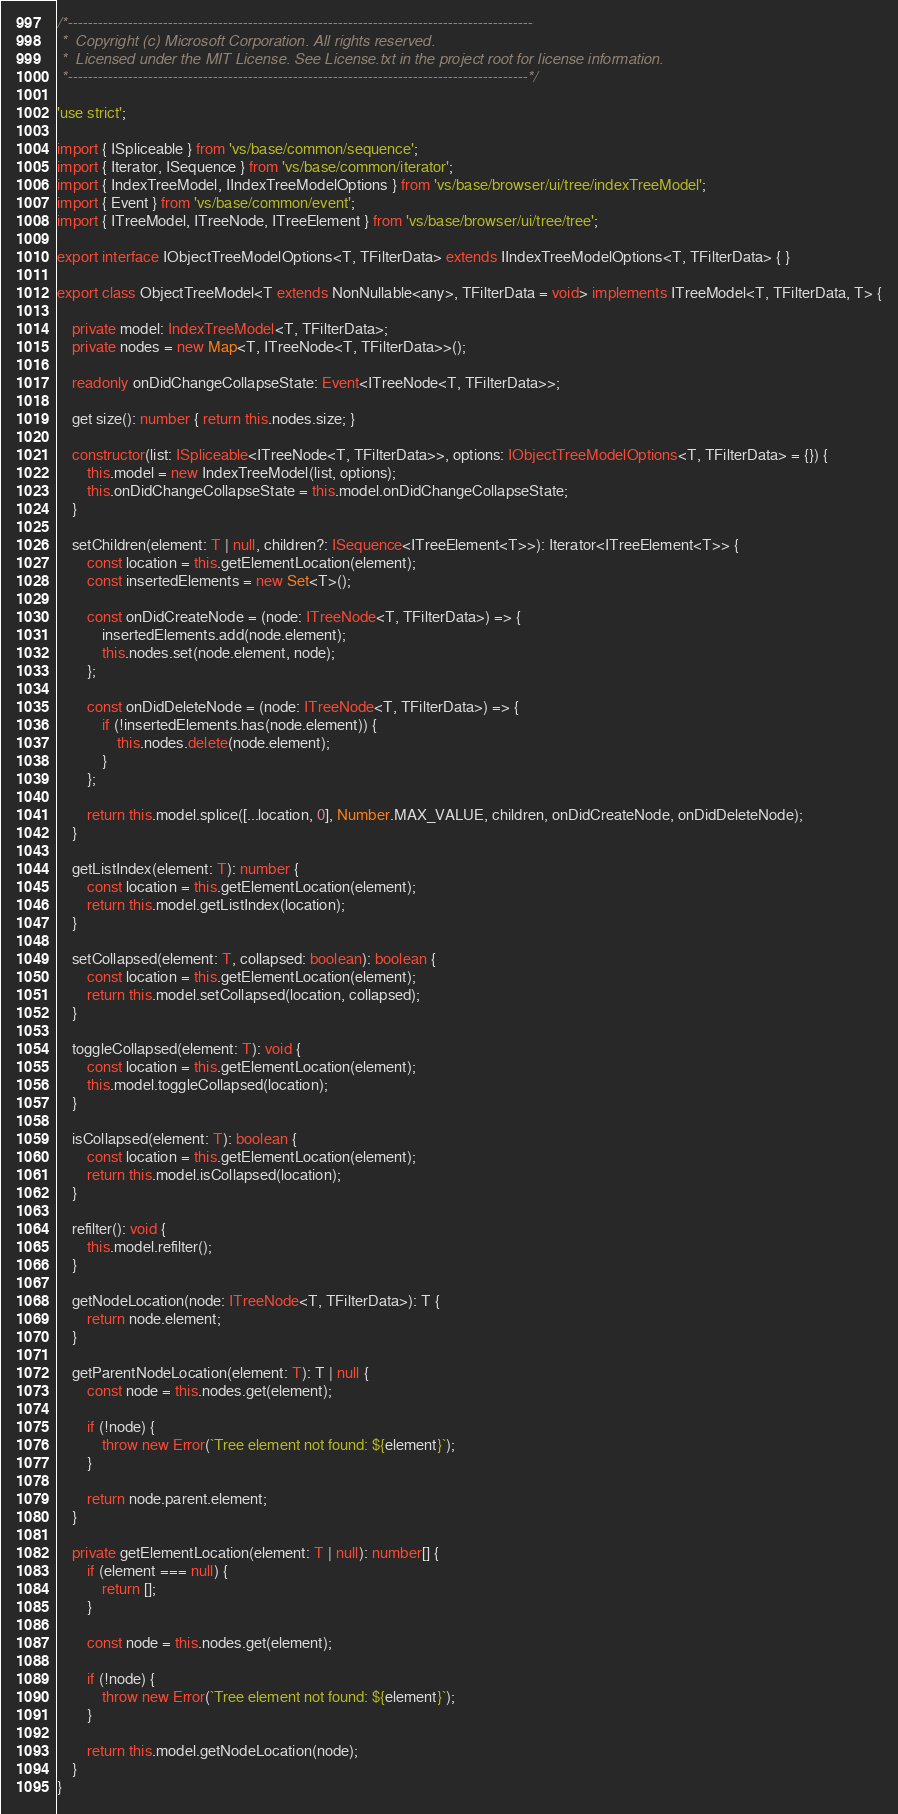<code> <loc_0><loc_0><loc_500><loc_500><_TypeScript_>/*---------------------------------------------------------------------------------------------
 *  Copyright (c) Microsoft Corporation. All rights reserved.
 *  Licensed under the MIT License. See License.txt in the project root for license information.
 *--------------------------------------------------------------------------------------------*/

'use strict';

import { ISpliceable } from 'vs/base/common/sequence';
import { Iterator, ISequence } from 'vs/base/common/iterator';
import { IndexTreeModel, IIndexTreeModelOptions } from 'vs/base/browser/ui/tree/indexTreeModel';
import { Event } from 'vs/base/common/event';
import { ITreeModel, ITreeNode, ITreeElement } from 'vs/base/browser/ui/tree/tree';

export interface IObjectTreeModelOptions<T, TFilterData> extends IIndexTreeModelOptions<T, TFilterData> { }

export class ObjectTreeModel<T extends NonNullable<any>, TFilterData = void> implements ITreeModel<T, TFilterData, T> {

	private model: IndexTreeModel<T, TFilterData>;
	private nodes = new Map<T, ITreeNode<T, TFilterData>>();

	readonly onDidChangeCollapseState: Event<ITreeNode<T, TFilterData>>;

	get size(): number { return this.nodes.size; }

	constructor(list: ISpliceable<ITreeNode<T, TFilterData>>, options: IObjectTreeModelOptions<T, TFilterData> = {}) {
		this.model = new IndexTreeModel(list, options);
		this.onDidChangeCollapseState = this.model.onDidChangeCollapseState;
	}

	setChildren(element: T | null, children?: ISequence<ITreeElement<T>>): Iterator<ITreeElement<T>> {
		const location = this.getElementLocation(element);
		const insertedElements = new Set<T>();

		const onDidCreateNode = (node: ITreeNode<T, TFilterData>) => {
			insertedElements.add(node.element);
			this.nodes.set(node.element, node);
		};

		const onDidDeleteNode = (node: ITreeNode<T, TFilterData>) => {
			if (!insertedElements.has(node.element)) {
				this.nodes.delete(node.element);
			}
		};

		return this.model.splice([...location, 0], Number.MAX_VALUE, children, onDidCreateNode, onDidDeleteNode);
	}

	getListIndex(element: T): number {
		const location = this.getElementLocation(element);
		return this.model.getListIndex(location);
	}

	setCollapsed(element: T, collapsed: boolean): boolean {
		const location = this.getElementLocation(element);
		return this.model.setCollapsed(location, collapsed);
	}

	toggleCollapsed(element: T): void {
		const location = this.getElementLocation(element);
		this.model.toggleCollapsed(location);
	}

	isCollapsed(element: T): boolean {
		const location = this.getElementLocation(element);
		return this.model.isCollapsed(location);
	}

	refilter(): void {
		this.model.refilter();
	}

	getNodeLocation(node: ITreeNode<T, TFilterData>): T {
		return node.element;
	}

	getParentNodeLocation(element: T): T | null {
		const node = this.nodes.get(element);

		if (!node) {
			throw new Error(`Tree element not found: ${element}`);
		}

		return node.parent.element;
	}

	private getElementLocation(element: T | null): number[] {
		if (element === null) {
			return [];
		}

		const node = this.nodes.get(element);

		if (!node) {
			throw new Error(`Tree element not found: ${element}`);
		}

		return this.model.getNodeLocation(node);
	}
}</code> 